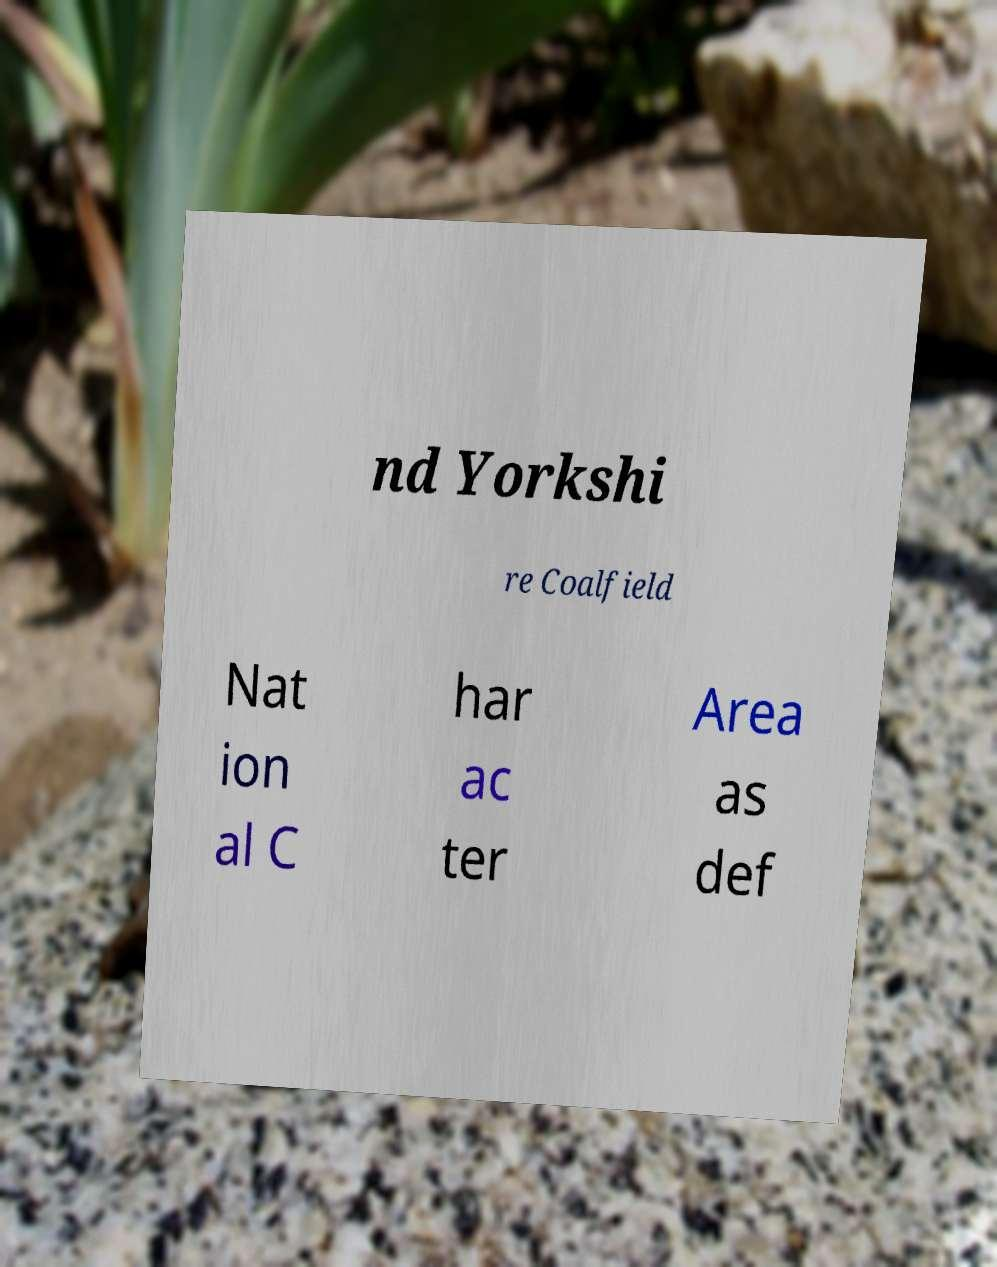Can you read and provide the text displayed in the image?This photo seems to have some interesting text. Can you extract and type it out for me? nd Yorkshi re Coalfield Nat ion al C har ac ter Area as def 